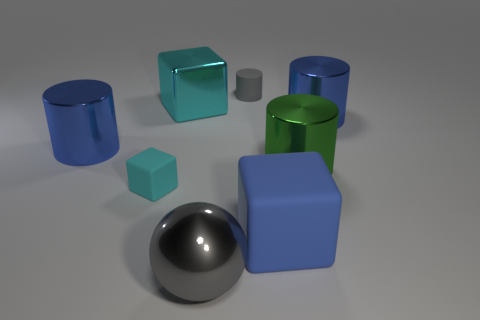Are there more small blue blocks than cylinders? After careful observation, there are an equal number of small blue blocks and cylinders present in the image, with both categories having two items each. 